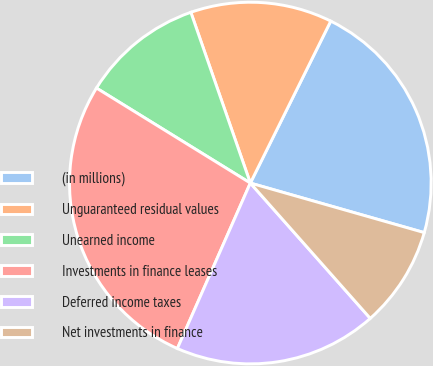Convert chart to OTSL. <chart><loc_0><loc_0><loc_500><loc_500><pie_chart><fcel>(in millions)<fcel>Unguaranteed residual values<fcel>Unearned income<fcel>Investments in finance leases<fcel>Deferred income taxes<fcel>Net investments in finance<nl><fcel>22.08%<fcel>12.67%<fcel>10.86%<fcel>27.19%<fcel>18.15%<fcel>9.04%<nl></chart> 